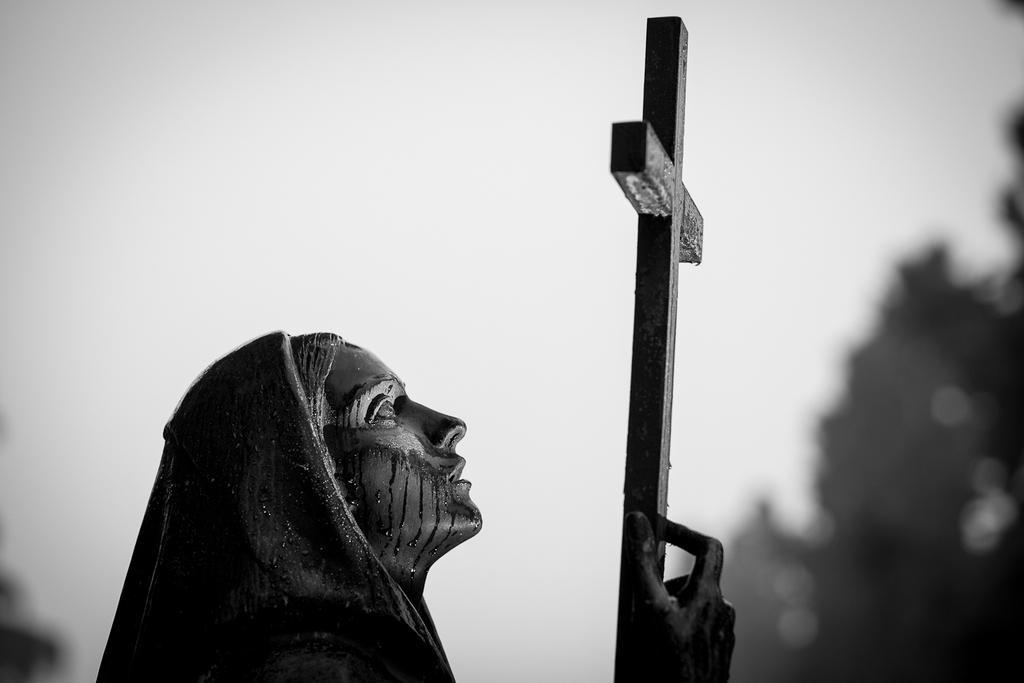Could you give a brief overview of what you see in this image? This is a black and white image and here we can see a statue. In the background, there are trees and there is sky. 